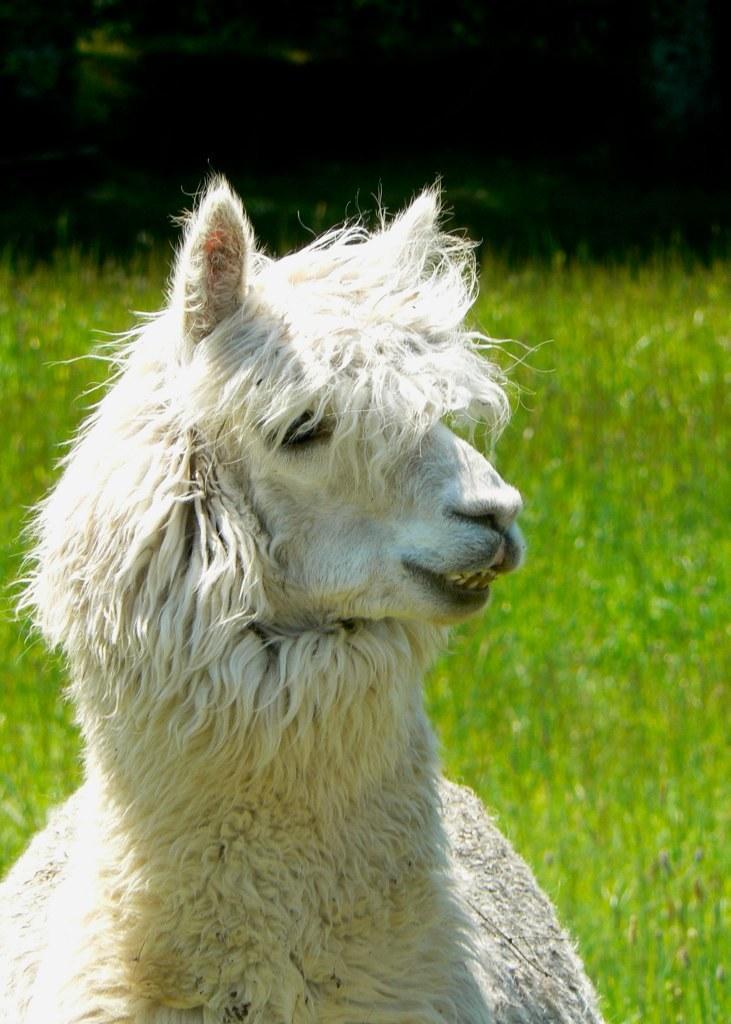How would you summarize this image in a sentence or two? In this image we can see an animal which is of white color. There is a green grassy land. 